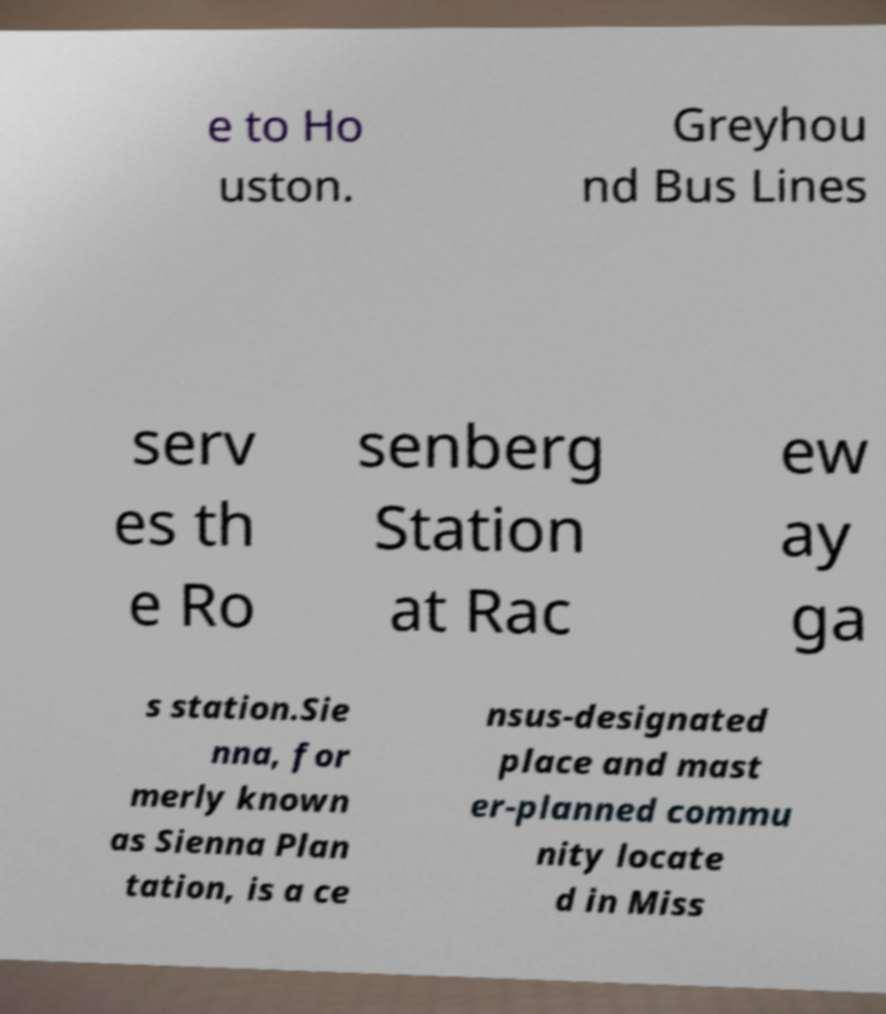What messages or text are displayed in this image? I need them in a readable, typed format. e to Ho uston. Greyhou nd Bus Lines serv es th e Ro senberg Station at Rac ew ay ga s station.Sie nna, for merly known as Sienna Plan tation, is a ce nsus-designated place and mast er-planned commu nity locate d in Miss 